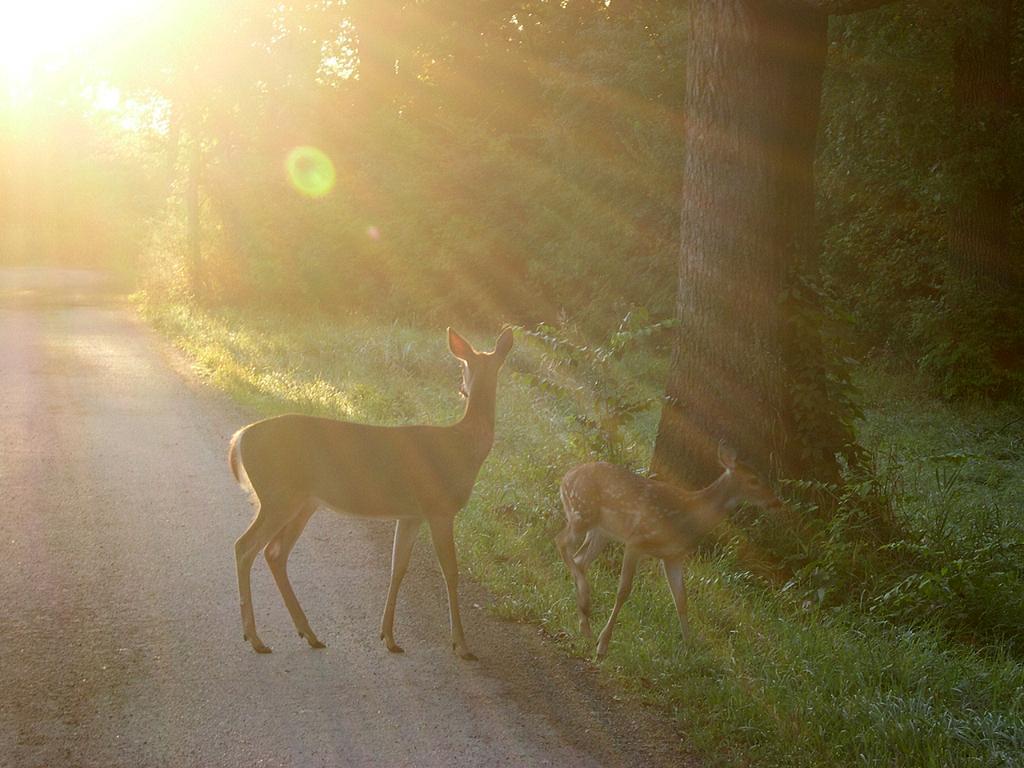Describe this image in one or two sentences. In this picture I can see deers are standing on the ground. In the background I can see a road, grass, plants, sunlight and trees. 